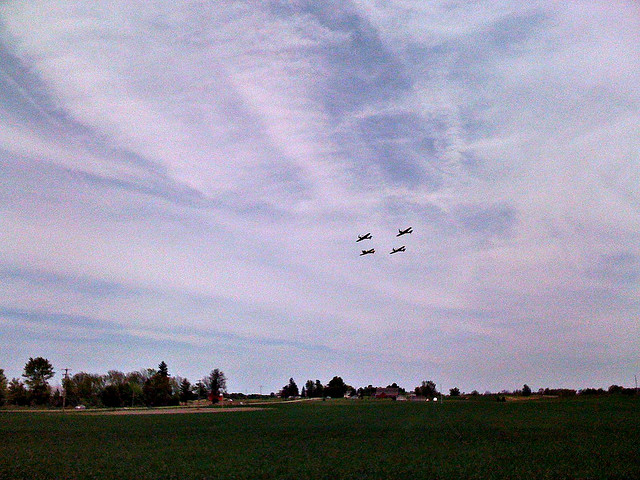<image>What type of jet is flying in the sky? I don't know what type of jet is flying in the sky. It can be an air force jet or a fighter jet. What type of jet is flying in the sky? It is ambiguous what type of jet is flying in the sky. It can be seen as air force jets, fighter jet or fighter jets. 